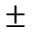Convert formula to latex. <formula><loc_0><loc_0><loc_500><loc_500>\pm</formula> 